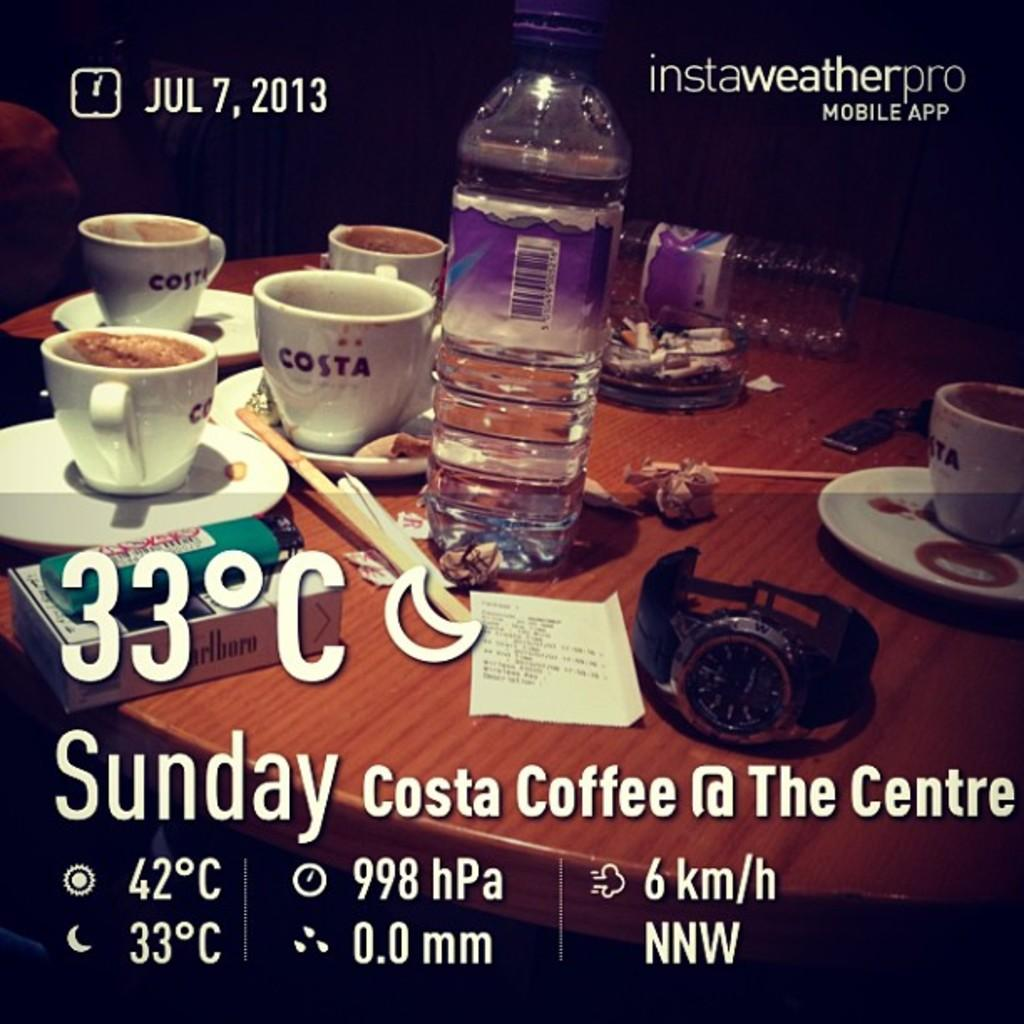Provide a one-sentence caption for the provided image. A table with four white cups with word costa written on them. 